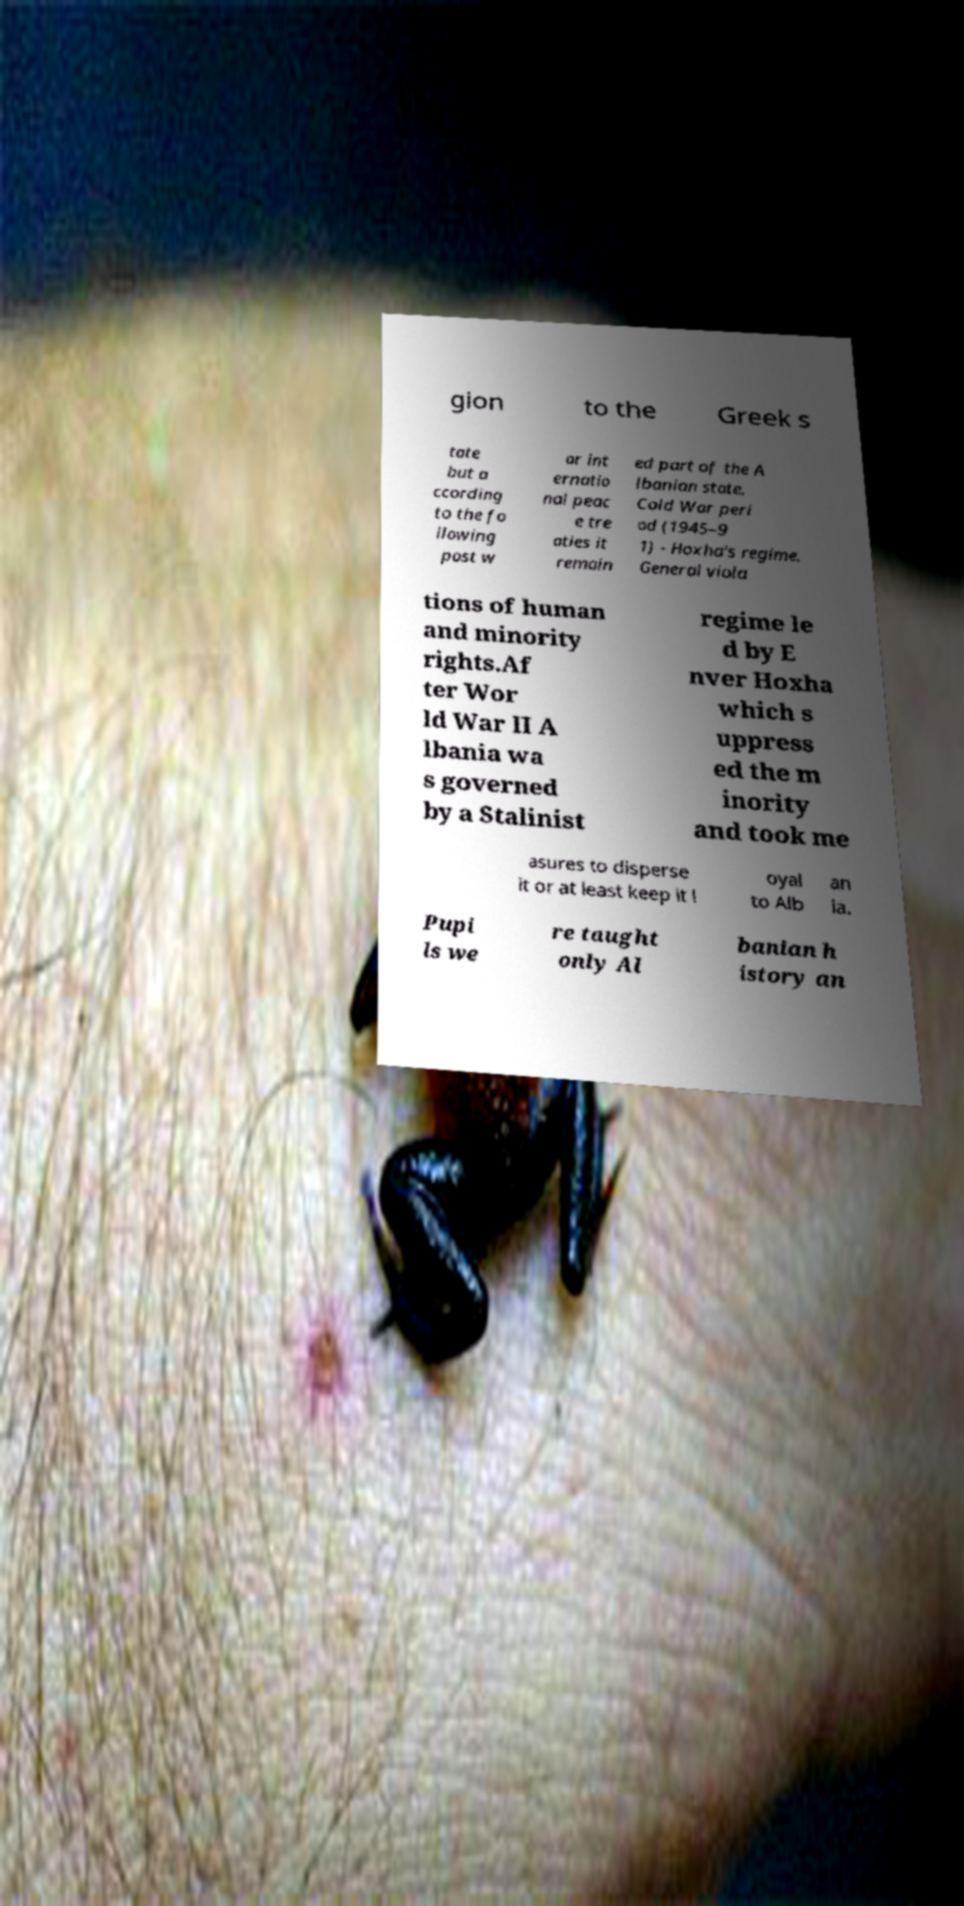Can you read and provide the text displayed in the image?This photo seems to have some interesting text. Can you extract and type it out for me? gion to the Greek s tate but a ccording to the fo llowing post w ar int ernatio nal peac e tre aties it remain ed part of the A lbanian state. Cold War peri od (1945–9 1) - Hoxha's regime. General viola tions of human and minority rights.Af ter Wor ld War II A lbania wa s governed by a Stalinist regime le d by E nver Hoxha which s uppress ed the m inority and took me asures to disperse it or at least keep it l oyal to Alb an ia. Pupi ls we re taught only Al banian h istory an 